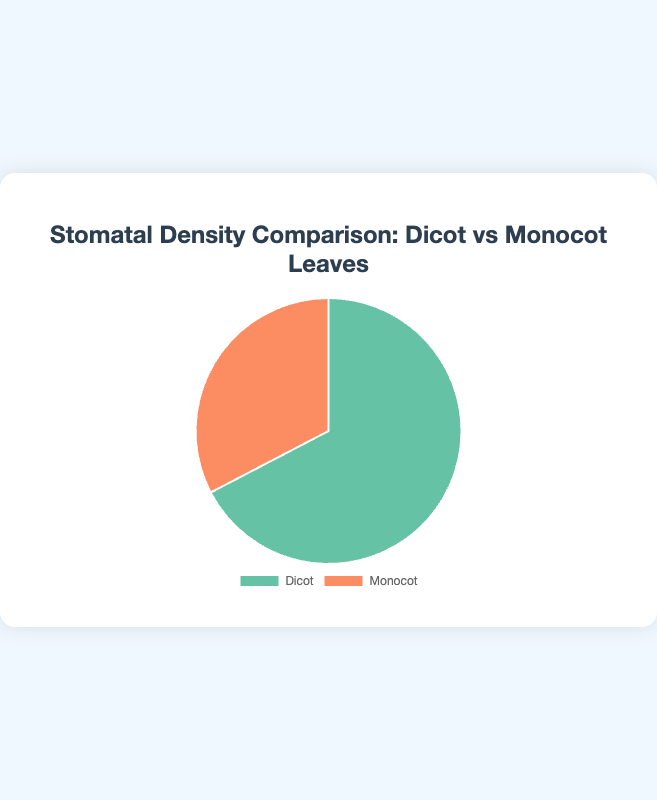What is the total stomatal density for dicots? To find the total stomatal density for dicots, sum the stomatal density of Arabidopsis thaliana (150) and Glycine max (180). The sum is 150 + 180 = 330.
Answer: 330 Which type of leaf has higher stomatal density, dicots or monocots? By comparing the total stomatal density, dicots have 330, and monocots have 160. Since 330 > 160, dicots have a higher stomatal density.
Answer: Dicots How much greater is the stomatal density of dicots compared to monocots? Subtract the total stomatal density of monocots (160) from that of dicots (330). The difference is 330 - 160 = 170.
Answer: 170 What is the average stomatal density for monocot leaves? To find the average, sum the stomatal density of Zea mays (70) and Oryza sativa (90), then divide by 2. The average is (70 + 90) / 2 = 80.
Answer: 80 What percentage of the total stomatal density does each leaf type contribute? First, calculate the total stomatal density: 330 (dicots) + 160 (monocots) = 490. For dicots: (330 / 490) * 100 = 67.3%. For monocots: (160 / 490) * 100 = 32.7%.
Answer: Dicots: 67.3%, Monocots: 32.7% Which leaf type is represented by the green portion of the pie chart? The pie chart is colored with the dicot section in green and the monocot section in orange. Therefore, the green portion represents dicots.
Answer: Dicots What is the difference in stomatal density between the species with the highest and lowest values? Between Glycine max (180) and Zea mays (70), calculate the difference: 180 - 70 = 110.
Answer: 110 